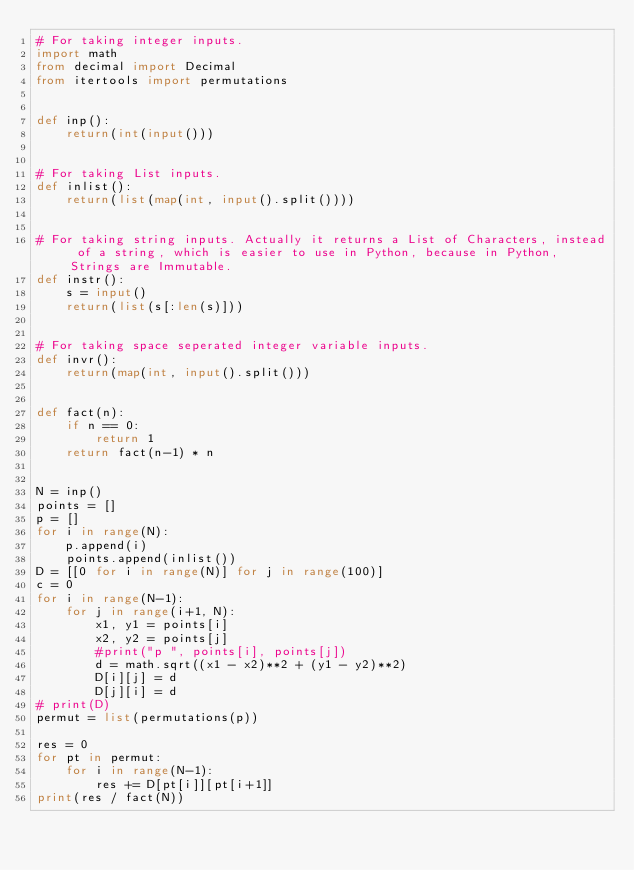Convert code to text. <code><loc_0><loc_0><loc_500><loc_500><_Python_># For taking integer inputs.
import math
from decimal import Decimal
from itertools import permutations


def inp():
    return(int(input()))


# For taking List inputs.
def inlist():
    return(list(map(int, input().split())))


# For taking string inputs. Actually it returns a List of Characters, instead of a string, which is easier to use in Python, because in Python, Strings are Immutable.
def instr():
    s = input()
    return(list(s[:len(s)]))


# For taking space seperated integer variable inputs.
def invr():
    return(map(int, input().split()))


def fact(n):
    if n == 0:
        return 1
    return fact(n-1) * n


N = inp()
points = []
p = []
for i in range(N):
    p.append(i)
    points.append(inlist())
D = [[0 for i in range(N)] for j in range(100)]
c = 0
for i in range(N-1):
    for j in range(i+1, N):
        x1, y1 = points[i]
        x2, y2 = points[j]
        #print("p ", points[i], points[j])
        d = math.sqrt((x1 - x2)**2 + (y1 - y2)**2)
        D[i][j] = d
        D[j][i] = d
# print(D)
permut = list(permutations(p))

res = 0
for pt in permut:
    for i in range(N-1):
        res += D[pt[i]][pt[i+1]]
print(res / fact(N))
</code> 